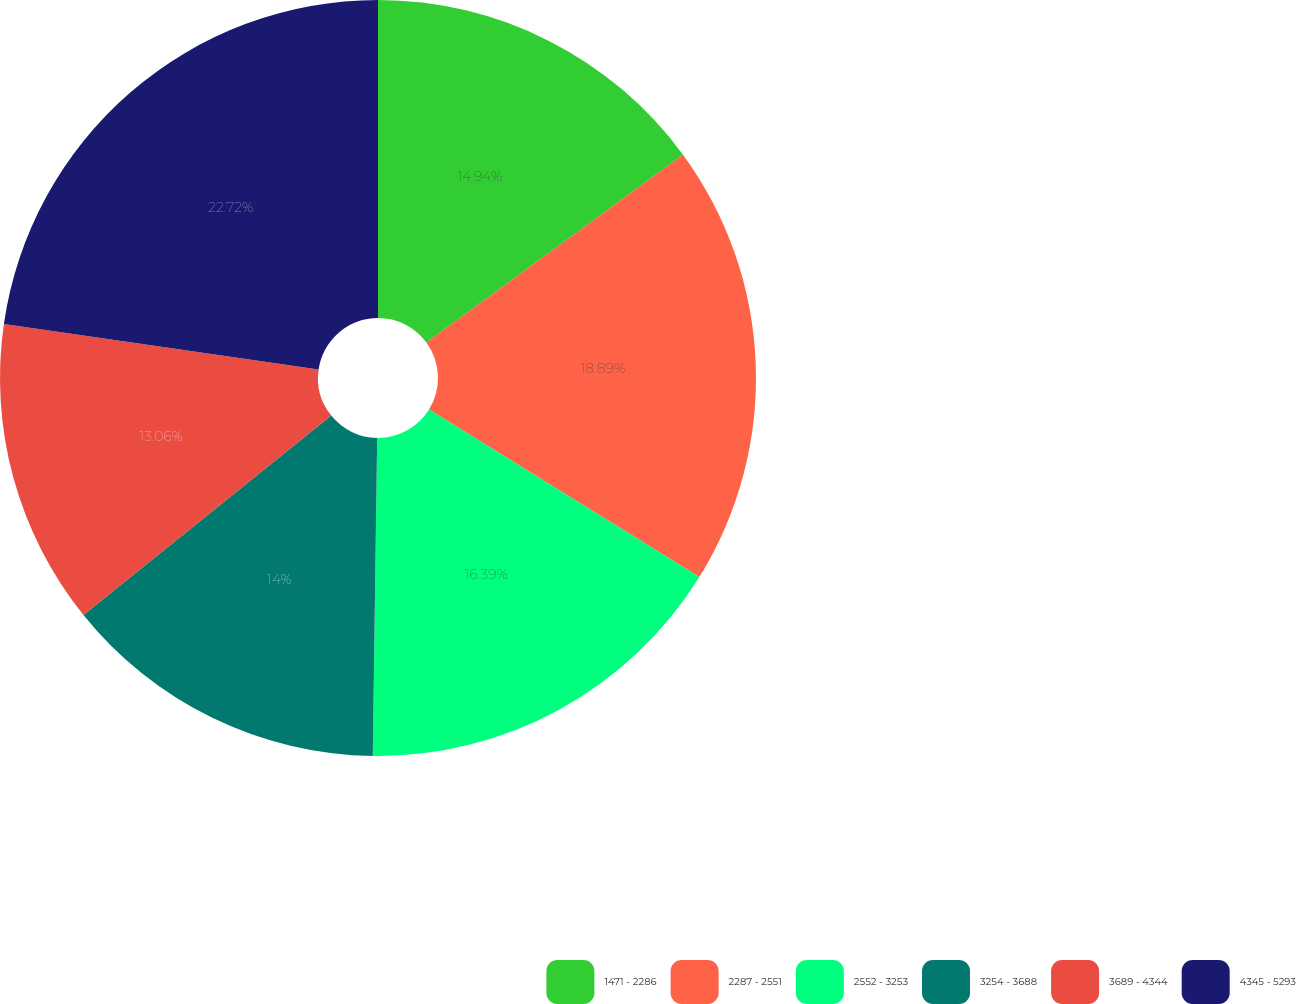Convert chart. <chart><loc_0><loc_0><loc_500><loc_500><pie_chart><fcel>1471 - 2286<fcel>2287 - 2551<fcel>2552 - 3253<fcel>3254 - 3688<fcel>3689 - 4344<fcel>4345 - 5293<nl><fcel>14.94%<fcel>18.89%<fcel>16.39%<fcel>14.0%<fcel>13.06%<fcel>22.72%<nl></chart> 